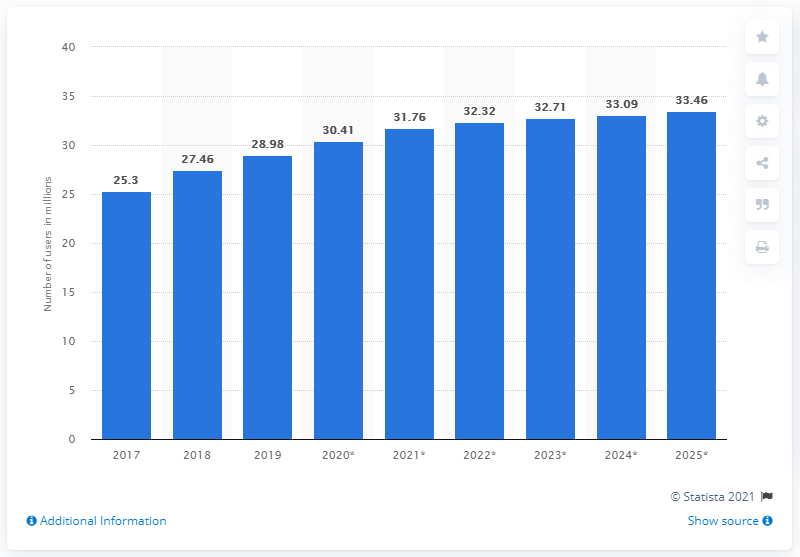Highlight a few significant elements in this photo. As of 2019, there were 28.98 million social network users in Malaysia. By 2025, it is estimated that there will be approximately 33.46 million social network users in Malaysia. 